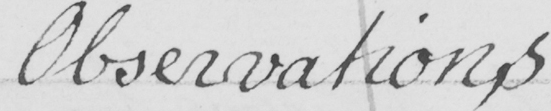Please transcribe the handwritten text in this image. Observation,s 